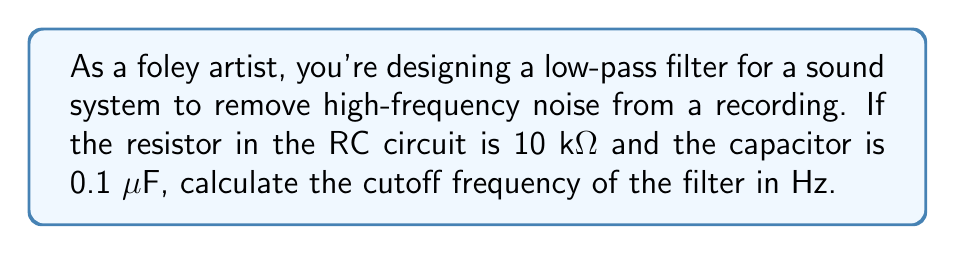Teach me how to tackle this problem. To solve this problem, we'll follow these steps:

1) The formula for the cutoff frequency of a low-pass RC filter is:

   $$f_c = \frac{1}{2\pi RC}$$

   Where:
   $f_c$ is the cutoff frequency in Hz
   $R$ is the resistance in ohms
   $C$ is the capacitance in farads

2) We're given:
   $R = 10 \text{ k}\Omega = 10,000 \Omega$
   $C = 0.1 \text{ μF} = 0.1 \times 10^{-6} \text{ F}$

3) Let's substitute these values into our formula:

   $$f_c = \frac{1}{2\pi (10,000)(0.1 \times 10^{-6})}$$

4) Simplify the denominator:

   $$f_c = \frac{1}{2\pi (1 \times 10^{-3})}$$

5) Calculate:

   $$f_c = \frac{1}{0.00628318} \approx 159.15 \text{ Hz}$$

6) Round to the nearest whole number:

   $$f_c \approx 159 \text{ Hz}$$

This cutoff frequency means that frequencies below 159 Hz will pass through the filter relatively unchanged, while frequencies above this will be attenuated.
Answer: 159 Hz 